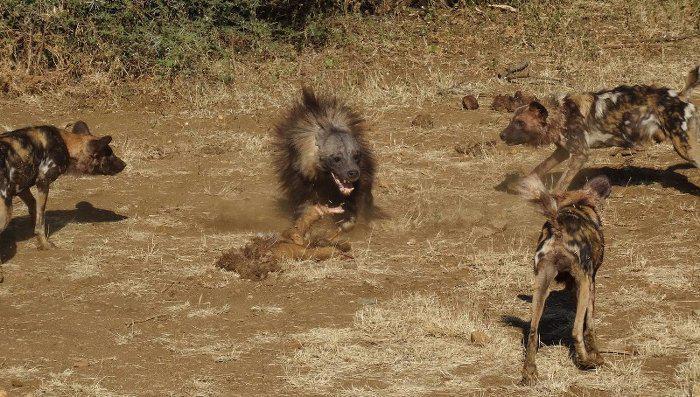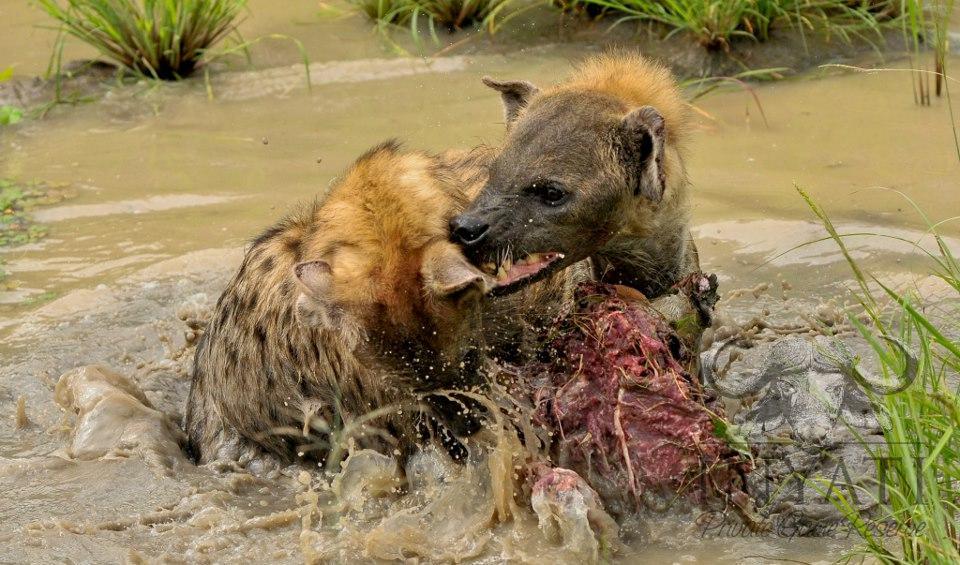The first image is the image on the left, the second image is the image on the right. Given the left and right images, does the statement "The right image has an animal looking to the left." hold true? Answer yes or no. Yes. The first image is the image on the left, the second image is the image on the right. Considering the images on both sides, is "At least two prairie dogs are looking straight ahead." valid? Answer yes or no. No. 